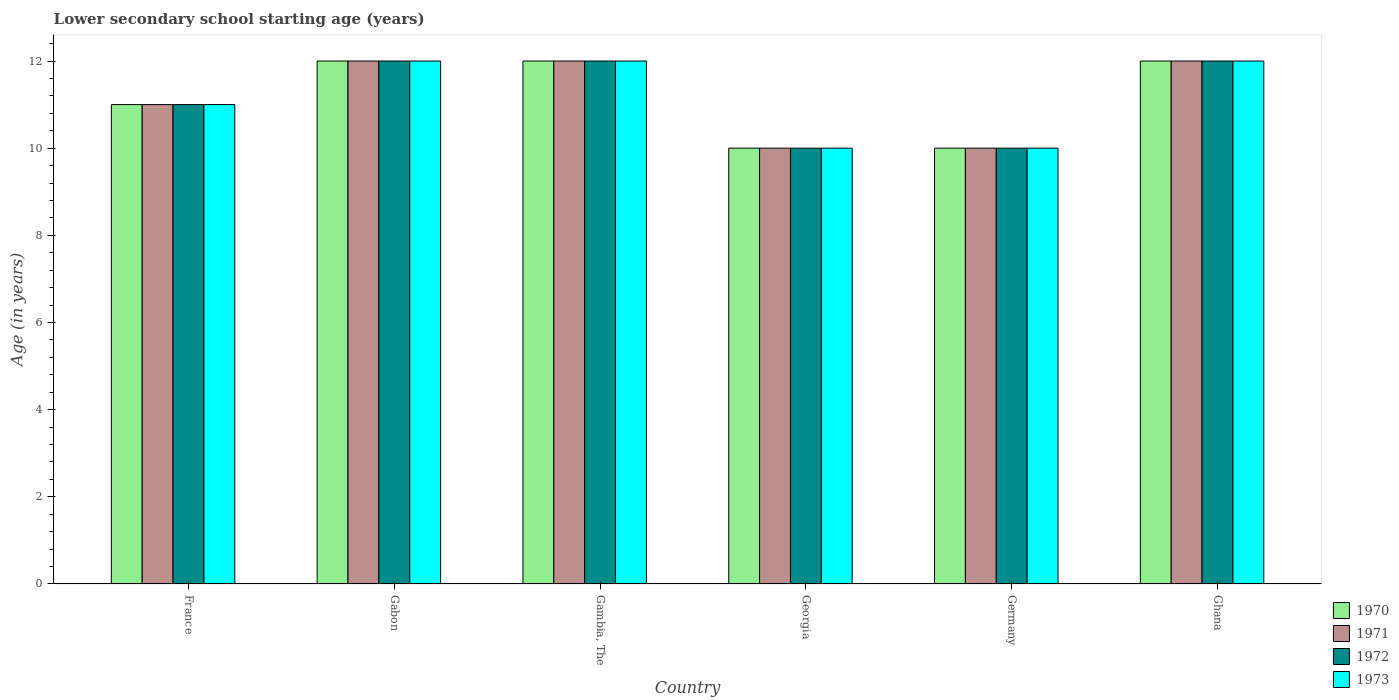How many different coloured bars are there?
Keep it short and to the point. 4. How many groups of bars are there?
Keep it short and to the point. 6. What is the label of the 3rd group of bars from the left?
Your response must be concise. Gambia, The. What is the lower secondary school starting age of children in 1972 in Germany?
Provide a short and direct response. 10. Across all countries, what is the maximum lower secondary school starting age of children in 1971?
Your answer should be very brief. 12. In which country was the lower secondary school starting age of children in 1970 maximum?
Ensure brevity in your answer.  Gabon. In which country was the lower secondary school starting age of children in 1972 minimum?
Your response must be concise. Georgia. What is the difference between the lower secondary school starting age of children in 1971 in Gabon and that in Ghana?
Keep it short and to the point. 0. What is the difference between the lower secondary school starting age of children in 1971 in Gambia, The and the lower secondary school starting age of children in 1970 in Gabon?
Keep it short and to the point. 0. What is the average lower secondary school starting age of children in 1971 per country?
Your answer should be compact. 11.17. In how many countries, is the lower secondary school starting age of children in 1971 greater than 4 years?
Ensure brevity in your answer.  6. What is the difference between the highest and the lowest lower secondary school starting age of children in 1970?
Your answer should be very brief. 2. In how many countries, is the lower secondary school starting age of children in 1970 greater than the average lower secondary school starting age of children in 1970 taken over all countries?
Your answer should be very brief. 3. What does the 2nd bar from the left in Germany represents?
Keep it short and to the point. 1971. How many bars are there?
Your response must be concise. 24. Does the graph contain any zero values?
Your answer should be compact. No. Does the graph contain grids?
Your answer should be compact. No. What is the title of the graph?
Ensure brevity in your answer.  Lower secondary school starting age (years). What is the label or title of the Y-axis?
Offer a very short reply. Age (in years). What is the Age (in years) of 1971 in France?
Make the answer very short. 11. What is the Age (in years) of 1972 in France?
Your answer should be very brief. 11. What is the Age (in years) in 1973 in France?
Keep it short and to the point. 11. What is the Age (in years) in 1971 in Gabon?
Ensure brevity in your answer.  12. What is the Age (in years) in 1972 in Gabon?
Your answer should be very brief. 12. What is the Age (in years) in 1973 in Gabon?
Your answer should be very brief. 12. What is the Age (in years) in 1970 in Gambia, The?
Make the answer very short. 12. What is the Age (in years) of 1972 in Georgia?
Keep it short and to the point. 10. What is the Age (in years) of 1973 in Georgia?
Your response must be concise. 10. What is the Age (in years) in 1970 in Germany?
Provide a short and direct response. 10. What is the Age (in years) in 1971 in Germany?
Provide a succinct answer. 10. What is the Age (in years) in 1972 in Germany?
Your answer should be very brief. 10. What is the Age (in years) of 1973 in Germany?
Offer a very short reply. 10. What is the Age (in years) of 1970 in Ghana?
Your response must be concise. 12. What is the Age (in years) of 1971 in Ghana?
Provide a succinct answer. 12. Across all countries, what is the maximum Age (in years) in 1970?
Your response must be concise. 12. Across all countries, what is the maximum Age (in years) in 1971?
Your response must be concise. 12. Across all countries, what is the minimum Age (in years) of 1970?
Provide a succinct answer. 10. Across all countries, what is the minimum Age (in years) of 1973?
Ensure brevity in your answer.  10. What is the total Age (in years) in 1970 in the graph?
Provide a succinct answer. 67. What is the total Age (in years) in 1971 in the graph?
Offer a very short reply. 67. What is the total Age (in years) in 1972 in the graph?
Ensure brevity in your answer.  67. What is the difference between the Age (in years) of 1971 in France and that in Gabon?
Make the answer very short. -1. What is the difference between the Age (in years) in 1973 in France and that in Gabon?
Make the answer very short. -1. What is the difference between the Age (in years) of 1973 in France and that in Gambia, The?
Your response must be concise. -1. What is the difference between the Age (in years) of 1972 in France and that in Georgia?
Make the answer very short. 1. What is the difference between the Age (in years) of 1973 in France and that in Georgia?
Give a very brief answer. 1. What is the difference between the Age (in years) in 1972 in France and that in Germany?
Your answer should be compact. 1. What is the difference between the Age (in years) in 1972 in France and that in Ghana?
Provide a short and direct response. -1. What is the difference between the Age (in years) in 1973 in France and that in Ghana?
Provide a short and direct response. -1. What is the difference between the Age (in years) in 1970 in Gabon and that in Gambia, The?
Provide a short and direct response. 0. What is the difference between the Age (in years) of 1972 in Gabon and that in Gambia, The?
Keep it short and to the point. 0. What is the difference between the Age (in years) in 1971 in Gabon and that in Georgia?
Provide a succinct answer. 2. What is the difference between the Age (in years) in 1973 in Gabon and that in Georgia?
Offer a very short reply. 2. What is the difference between the Age (in years) in 1970 in Gabon and that in Germany?
Give a very brief answer. 2. What is the difference between the Age (in years) of 1971 in Gabon and that in Germany?
Offer a terse response. 2. What is the difference between the Age (in years) in 1973 in Gabon and that in Ghana?
Ensure brevity in your answer.  0. What is the difference between the Age (in years) in 1970 in Gambia, The and that in Georgia?
Your answer should be very brief. 2. What is the difference between the Age (in years) of 1971 in Gambia, The and that in Georgia?
Provide a succinct answer. 2. What is the difference between the Age (in years) of 1972 in Gambia, The and that in Georgia?
Ensure brevity in your answer.  2. What is the difference between the Age (in years) in 1973 in Gambia, The and that in Georgia?
Your response must be concise. 2. What is the difference between the Age (in years) in 1970 in Gambia, The and that in Germany?
Ensure brevity in your answer.  2. What is the difference between the Age (in years) of 1972 in Gambia, The and that in Germany?
Your answer should be compact. 2. What is the difference between the Age (in years) in 1973 in Gambia, The and that in Germany?
Offer a very short reply. 2. What is the difference between the Age (in years) in 1972 in Gambia, The and that in Ghana?
Offer a very short reply. 0. What is the difference between the Age (in years) in 1973 in Gambia, The and that in Ghana?
Ensure brevity in your answer.  0. What is the difference between the Age (in years) in 1970 in Georgia and that in Germany?
Your response must be concise. 0. What is the difference between the Age (in years) in 1971 in Georgia and that in Ghana?
Your answer should be very brief. -2. What is the difference between the Age (in years) in 1971 in Germany and that in Ghana?
Provide a short and direct response. -2. What is the difference between the Age (in years) in 1972 in Germany and that in Ghana?
Your response must be concise. -2. What is the difference between the Age (in years) of 1970 in France and the Age (in years) of 1971 in Gabon?
Give a very brief answer. -1. What is the difference between the Age (in years) in 1970 in France and the Age (in years) in 1973 in Gabon?
Provide a succinct answer. -1. What is the difference between the Age (in years) of 1970 in France and the Age (in years) of 1972 in Gambia, The?
Offer a very short reply. -1. What is the difference between the Age (in years) of 1971 in France and the Age (in years) of 1973 in Gambia, The?
Your answer should be very brief. -1. What is the difference between the Age (in years) of 1972 in France and the Age (in years) of 1973 in Gambia, The?
Provide a short and direct response. -1. What is the difference between the Age (in years) of 1971 in France and the Age (in years) of 1972 in Georgia?
Keep it short and to the point. 1. What is the difference between the Age (in years) in 1971 in France and the Age (in years) in 1973 in Georgia?
Your response must be concise. 1. What is the difference between the Age (in years) in 1972 in France and the Age (in years) in 1973 in Georgia?
Provide a short and direct response. 1. What is the difference between the Age (in years) in 1970 in France and the Age (in years) in 1972 in Germany?
Ensure brevity in your answer.  1. What is the difference between the Age (in years) in 1970 in France and the Age (in years) in 1973 in Germany?
Your answer should be very brief. 1. What is the difference between the Age (in years) of 1971 in France and the Age (in years) of 1972 in Germany?
Your answer should be compact. 1. What is the difference between the Age (in years) of 1972 in France and the Age (in years) of 1973 in Germany?
Your response must be concise. 1. What is the difference between the Age (in years) of 1970 in France and the Age (in years) of 1971 in Ghana?
Provide a succinct answer. -1. What is the difference between the Age (in years) of 1970 in France and the Age (in years) of 1973 in Ghana?
Provide a short and direct response. -1. What is the difference between the Age (in years) in 1972 in France and the Age (in years) in 1973 in Ghana?
Provide a succinct answer. -1. What is the difference between the Age (in years) of 1970 in Gabon and the Age (in years) of 1972 in Gambia, The?
Give a very brief answer. 0. What is the difference between the Age (in years) of 1971 in Gabon and the Age (in years) of 1972 in Gambia, The?
Provide a succinct answer. 0. What is the difference between the Age (in years) of 1972 in Gabon and the Age (in years) of 1973 in Gambia, The?
Offer a very short reply. 0. What is the difference between the Age (in years) in 1970 in Gabon and the Age (in years) in 1972 in Georgia?
Provide a short and direct response. 2. What is the difference between the Age (in years) in 1970 in Gabon and the Age (in years) in 1973 in Georgia?
Make the answer very short. 2. What is the difference between the Age (in years) in 1970 in Gabon and the Age (in years) in 1971 in Germany?
Keep it short and to the point. 2. What is the difference between the Age (in years) of 1971 in Gabon and the Age (in years) of 1973 in Germany?
Your response must be concise. 2. What is the difference between the Age (in years) of 1972 in Gabon and the Age (in years) of 1973 in Germany?
Your answer should be compact. 2. What is the difference between the Age (in years) of 1972 in Gabon and the Age (in years) of 1973 in Ghana?
Offer a terse response. 0. What is the difference between the Age (in years) of 1970 in Gambia, The and the Age (in years) of 1971 in Georgia?
Make the answer very short. 2. What is the difference between the Age (in years) of 1970 in Gambia, The and the Age (in years) of 1973 in Georgia?
Provide a short and direct response. 2. What is the difference between the Age (in years) of 1970 in Gambia, The and the Age (in years) of 1972 in Germany?
Offer a very short reply. 2. What is the difference between the Age (in years) in 1970 in Gambia, The and the Age (in years) in 1973 in Germany?
Offer a very short reply. 2. What is the difference between the Age (in years) of 1970 in Gambia, The and the Age (in years) of 1971 in Ghana?
Offer a terse response. 0. What is the difference between the Age (in years) of 1970 in Gambia, The and the Age (in years) of 1973 in Ghana?
Ensure brevity in your answer.  0. What is the difference between the Age (in years) of 1972 in Gambia, The and the Age (in years) of 1973 in Ghana?
Your response must be concise. 0. What is the difference between the Age (in years) of 1970 in Georgia and the Age (in years) of 1972 in Germany?
Ensure brevity in your answer.  0. What is the difference between the Age (in years) in 1972 in Georgia and the Age (in years) in 1973 in Germany?
Make the answer very short. 0. What is the difference between the Age (in years) of 1970 in Georgia and the Age (in years) of 1971 in Ghana?
Keep it short and to the point. -2. What is the difference between the Age (in years) in 1970 in Georgia and the Age (in years) in 1973 in Ghana?
Give a very brief answer. -2. What is the difference between the Age (in years) in 1970 in Germany and the Age (in years) in 1973 in Ghana?
Keep it short and to the point. -2. What is the difference between the Age (in years) in 1971 in Germany and the Age (in years) in 1972 in Ghana?
Provide a short and direct response. -2. What is the average Age (in years) in 1970 per country?
Give a very brief answer. 11.17. What is the average Age (in years) of 1971 per country?
Your answer should be very brief. 11.17. What is the average Age (in years) in 1972 per country?
Give a very brief answer. 11.17. What is the average Age (in years) of 1973 per country?
Your answer should be very brief. 11.17. What is the difference between the Age (in years) of 1970 and Age (in years) of 1971 in France?
Provide a succinct answer. 0. What is the difference between the Age (in years) in 1970 and Age (in years) in 1973 in France?
Give a very brief answer. 0. What is the difference between the Age (in years) in 1971 and Age (in years) in 1972 in France?
Ensure brevity in your answer.  0. What is the difference between the Age (in years) in 1971 and Age (in years) in 1973 in France?
Provide a short and direct response. 0. What is the difference between the Age (in years) in 1972 and Age (in years) in 1973 in France?
Your response must be concise. 0. What is the difference between the Age (in years) in 1970 and Age (in years) in 1973 in Gabon?
Offer a very short reply. 0. What is the difference between the Age (in years) in 1971 and Age (in years) in 1972 in Gabon?
Keep it short and to the point. 0. What is the difference between the Age (in years) in 1971 and Age (in years) in 1973 in Gabon?
Your answer should be compact. 0. What is the difference between the Age (in years) of 1972 and Age (in years) of 1973 in Gabon?
Make the answer very short. 0. What is the difference between the Age (in years) of 1970 and Age (in years) of 1971 in Gambia, The?
Offer a terse response. 0. What is the difference between the Age (in years) of 1970 and Age (in years) of 1972 in Gambia, The?
Make the answer very short. 0. What is the difference between the Age (in years) in 1970 and Age (in years) in 1973 in Gambia, The?
Give a very brief answer. 0. What is the difference between the Age (in years) in 1971 and Age (in years) in 1972 in Gambia, The?
Provide a succinct answer. 0. What is the difference between the Age (in years) of 1971 and Age (in years) of 1973 in Gambia, The?
Offer a terse response. 0. What is the difference between the Age (in years) of 1970 and Age (in years) of 1972 in Georgia?
Your answer should be compact. 0. What is the difference between the Age (in years) of 1970 and Age (in years) of 1973 in Georgia?
Give a very brief answer. 0. What is the difference between the Age (in years) of 1971 and Age (in years) of 1972 in Georgia?
Ensure brevity in your answer.  0. What is the difference between the Age (in years) of 1972 and Age (in years) of 1973 in Georgia?
Offer a terse response. 0. What is the difference between the Age (in years) in 1971 and Age (in years) in 1973 in Germany?
Offer a terse response. 0. What is the difference between the Age (in years) of 1970 and Age (in years) of 1971 in Ghana?
Your response must be concise. 0. What is the difference between the Age (in years) of 1971 and Age (in years) of 1972 in Ghana?
Make the answer very short. 0. What is the difference between the Age (in years) in 1971 and Age (in years) in 1973 in Ghana?
Your answer should be compact. 0. What is the difference between the Age (in years) of 1972 and Age (in years) of 1973 in Ghana?
Your response must be concise. 0. What is the ratio of the Age (in years) in 1970 in France to that in Gabon?
Provide a short and direct response. 0.92. What is the ratio of the Age (in years) in 1971 in France to that in Gabon?
Offer a terse response. 0.92. What is the ratio of the Age (in years) of 1972 in France to that in Gabon?
Provide a succinct answer. 0.92. What is the ratio of the Age (in years) of 1972 in France to that in Gambia, The?
Give a very brief answer. 0.92. What is the ratio of the Age (in years) of 1971 in France to that in Georgia?
Give a very brief answer. 1.1. What is the ratio of the Age (in years) in 1972 in France to that in Georgia?
Provide a succinct answer. 1.1. What is the ratio of the Age (in years) of 1973 in France to that in Georgia?
Your response must be concise. 1.1. What is the ratio of the Age (in years) in 1971 in France to that in Germany?
Keep it short and to the point. 1.1. What is the ratio of the Age (in years) in 1972 in France to that in Germany?
Offer a terse response. 1.1. What is the ratio of the Age (in years) in 1971 in France to that in Ghana?
Make the answer very short. 0.92. What is the ratio of the Age (in years) of 1972 in France to that in Ghana?
Keep it short and to the point. 0.92. What is the ratio of the Age (in years) of 1973 in France to that in Ghana?
Keep it short and to the point. 0.92. What is the ratio of the Age (in years) in 1970 in Gabon to that in Gambia, The?
Offer a very short reply. 1. What is the ratio of the Age (in years) of 1971 in Gabon to that in Gambia, The?
Your answer should be compact. 1. What is the ratio of the Age (in years) of 1973 in Gabon to that in Georgia?
Your response must be concise. 1.2. What is the ratio of the Age (in years) of 1970 in Gabon to that in Germany?
Your response must be concise. 1.2. What is the ratio of the Age (in years) in 1973 in Gabon to that in Germany?
Your response must be concise. 1.2. What is the ratio of the Age (in years) of 1972 in Gabon to that in Ghana?
Your answer should be very brief. 1. What is the ratio of the Age (in years) in 1970 in Gambia, The to that in Georgia?
Your answer should be compact. 1.2. What is the ratio of the Age (in years) in 1971 in Gambia, The to that in Georgia?
Offer a terse response. 1.2. What is the ratio of the Age (in years) of 1970 in Gambia, The to that in Germany?
Give a very brief answer. 1.2. What is the ratio of the Age (in years) of 1971 in Gambia, The to that in Germany?
Offer a very short reply. 1.2. What is the ratio of the Age (in years) of 1972 in Gambia, The to that in Germany?
Provide a short and direct response. 1.2. What is the ratio of the Age (in years) of 1973 in Gambia, The to that in Germany?
Give a very brief answer. 1.2. What is the ratio of the Age (in years) of 1970 in Gambia, The to that in Ghana?
Ensure brevity in your answer.  1. What is the ratio of the Age (in years) in 1972 in Gambia, The to that in Ghana?
Provide a succinct answer. 1. What is the ratio of the Age (in years) of 1970 in Georgia to that in Germany?
Ensure brevity in your answer.  1. What is the ratio of the Age (in years) in 1972 in Georgia to that in Germany?
Your response must be concise. 1. What is the ratio of the Age (in years) in 1973 in Georgia to that in Germany?
Your answer should be very brief. 1. What is the ratio of the Age (in years) of 1970 in Georgia to that in Ghana?
Ensure brevity in your answer.  0.83. What is the ratio of the Age (in years) of 1970 in Germany to that in Ghana?
Your response must be concise. 0.83. What is the ratio of the Age (in years) in 1971 in Germany to that in Ghana?
Keep it short and to the point. 0.83. What is the difference between the highest and the second highest Age (in years) of 1970?
Offer a terse response. 0. What is the difference between the highest and the lowest Age (in years) in 1971?
Offer a very short reply. 2. What is the difference between the highest and the lowest Age (in years) in 1973?
Give a very brief answer. 2. 